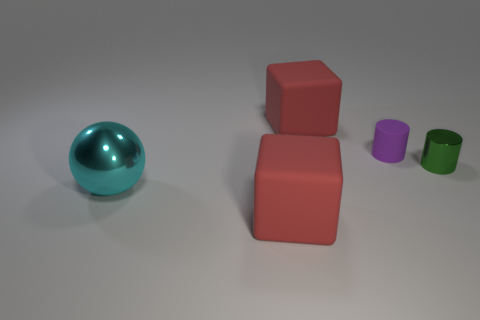Is the number of small metal cylinders in front of the green metallic cylinder less than the number of big matte cubes that are behind the big metal thing?
Keep it short and to the point. Yes. Is there any other thing that is the same shape as the purple object?
Offer a terse response. Yes. What is the color of the other small shiny object that is the same shape as the small purple thing?
Make the answer very short. Green. There is a purple matte thing; does it have the same shape as the big red rubber thing that is in front of the purple thing?
Give a very brief answer. No. How many objects are either large cubes behind the cyan metal object or red matte blocks that are behind the green object?
Your response must be concise. 1. What material is the big cyan object?
Provide a succinct answer. Metal. What number of other objects are the same size as the green metal cylinder?
Give a very brief answer. 1. What size is the matte cube that is behind the green shiny cylinder?
Provide a succinct answer. Large. What material is the thing on the left side of the large rubber cube in front of the tiny purple cylinder behind the green shiny object?
Keep it short and to the point. Metal. Is the big metal thing the same shape as the tiny green metal object?
Keep it short and to the point. No. 